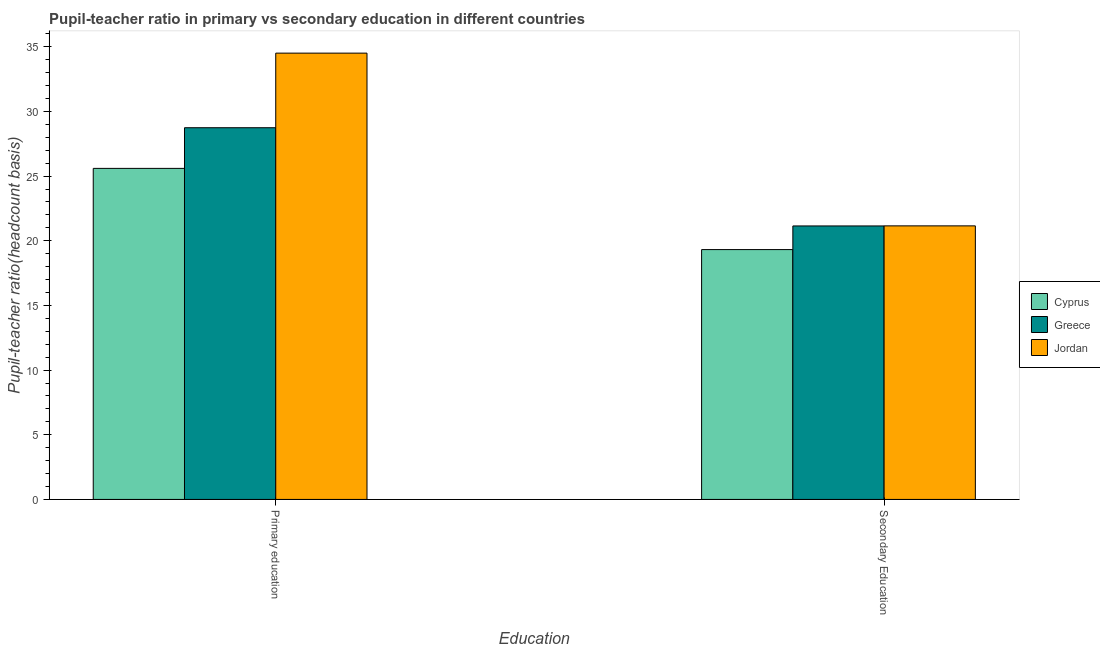How many groups of bars are there?
Provide a short and direct response. 2. Are the number of bars per tick equal to the number of legend labels?
Keep it short and to the point. Yes. What is the label of the 2nd group of bars from the left?
Your response must be concise. Secondary Education. What is the pupil-teacher ratio in primary education in Jordan?
Provide a short and direct response. 34.51. Across all countries, what is the maximum pupil teacher ratio on secondary education?
Provide a short and direct response. 21.15. Across all countries, what is the minimum pupil teacher ratio on secondary education?
Ensure brevity in your answer.  19.32. In which country was the pupil teacher ratio on secondary education maximum?
Keep it short and to the point. Jordan. In which country was the pupil-teacher ratio in primary education minimum?
Offer a very short reply. Cyprus. What is the total pupil-teacher ratio in primary education in the graph?
Provide a succinct answer. 88.85. What is the difference between the pupil teacher ratio on secondary education in Cyprus and that in Greece?
Provide a succinct answer. -1.83. What is the difference between the pupil-teacher ratio in primary education in Jordan and the pupil teacher ratio on secondary education in Greece?
Your answer should be very brief. 13.36. What is the average pupil-teacher ratio in primary education per country?
Keep it short and to the point. 29.62. What is the difference between the pupil teacher ratio on secondary education and pupil-teacher ratio in primary education in Greece?
Give a very brief answer. -7.59. In how many countries, is the pupil teacher ratio on secondary education greater than 1 ?
Provide a succinct answer. 3. What is the ratio of the pupil-teacher ratio in primary education in Jordan to that in Greece?
Keep it short and to the point. 1.2. Is the pupil teacher ratio on secondary education in Cyprus less than that in Jordan?
Provide a succinct answer. Yes. In how many countries, is the pupil-teacher ratio in primary education greater than the average pupil-teacher ratio in primary education taken over all countries?
Your answer should be compact. 1. What does the 1st bar from the left in Primary education represents?
Keep it short and to the point. Cyprus. What does the 3rd bar from the right in Primary education represents?
Ensure brevity in your answer.  Cyprus. How many bars are there?
Provide a succinct answer. 6. How many countries are there in the graph?
Your answer should be compact. 3. Are the values on the major ticks of Y-axis written in scientific E-notation?
Give a very brief answer. No. Does the graph contain any zero values?
Keep it short and to the point. No. What is the title of the graph?
Make the answer very short. Pupil-teacher ratio in primary vs secondary education in different countries. Does "Malaysia" appear as one of the legend labels in the graph?
Ensure brevity in your answer.  No. What is the label or title of the X-axis?
Ensure brevity in your answer.  Education. What is the label or title of the Y-axis?
Your answer should be compact. Pupil-teacher ratio(headcount basis). What is the Pupil-teacher ratio(headcount basis) in Cyprus in Primary education?
Provide a short and direct response. 25.6. What is the Pupil-teacher ratio(headcount basis) of Greece in Primary education?
Provide a short and direct response. 28.74. What is the Pupil-teacher ratio(headcount basis) of Jordan in Primary education?
Give a very brief answer. 34.51. What is the Pupil-teacher ratio(headcount basis) of Cyprus in Secondary Education?
Provide a succinct answer. 19.32. What is the Pupil-teacher ratio(headcount basis) of Greece in Secondary Education?
Give a very brief answer. 21.15. What is the Pupil-teacher ratio(headcount basis) in Jordan in Secondary Education?
Keep it short and to the point. 21.15. Across all Education, what is the maximum Pupil-teacher ratio(headcount basis) of Cyprus?
Give a very brief answer. 25.6. Across all Education, what is the maximum Pupil-teacher ratio(headcount basis) of Greece?
Your response must be concise. 28.74. Across all Education, what is the maximum Pupil-teacher ratio(headcount basis) of Jordan?
Your response must be concise. 34.51. Across all Education, what is the minimum Pupil-teacher ratio(headcount basis) of Cyprus?
Ensure brevity in your answer.  19.32. Across all Education, what is the minimum Pupil-teacher ratio(headcount basis) of Greece?
Your response must be concise. 21.15. Across all Education, what is the minimum Pupil-teacher ratio(headcount basis) of Jordan?
Offer a terse response. 21.15. What is the total Pupil-teacher ratio(headcount basis) in Cyprus in the graph?
Provide a short and direct response. 44.92. What is the total Pupil-teacher ratio(headcount basis) in Greece in the graph?
Give a very brief answer. 49.89. What is the total Pupil-teacher ratio(headcount basis) of Jordan in the graph?
Provide a short and direct response. 55.66. What is the difference between the Pupil-teacher ratio(headcount basis) in Cyprus in Primary education and that in Secondary Education?
Your answer should be very brief. 6.28. What is the difference between the Pupil-teacher ratio(headcount basis) of Greece in Primary education and that in Secondary Education?
Provide a succinct answer. 7.59. What is the difference between the Pupil-teacher ratio(headcount basis) in Jordan in Primary education and that in Secondary Education?
Provide a short and direct response. 13.36. What is the difference between the Pupil-teacher ratio(headcount basis) of Cyprus in Primary education and the Pupil-teacher ratio(headcount basis) of Greece in Secondary Education?
Provide a short and direct response. 4.45. What is the difference between the Pupil-teacher ratio(headcount basis) of Cyprus in Primary education and the Pupil-teacher ratio(headcount basis) of Jordan in Secondary Education?
Offer a very short reply. 4.44. What is the difference between the Pupil-teacher ratio(headcount basis) of Greece in Primary education and the Pupil-teacher ratio(headcount basis) of Jordan in Secondary Education?
Your response must be concise. 7.59. What is the average Pupil-teacher ratio(headcount basis) in Cyprus per Education?
Make the answer very short. 22.46. What is the average Pupil-teacher ratio(headcount basis) in Greece per Education?
Provide a short and direct response. 24.94. What is the average Pupil-teacher ratio(headcount basis) in Jordan per Education?
Offer a very short reply. 27.83. What is the difference between the Pupil-teacher ratio(headcount basis) of Cyprus and Pupil-teacher ratio(headcount basis) of Greece in Primary education?
Your answer should be compact. -3.14. What is the difference between the Pupil-teacher ratio(headcount basis) of Cyprus and Pupil-teacher ratio(headcount basis) of Jordan in Primary education?
Your answer should be very brief. -8.91. What is the difference between the Pupil-teacher ratio(headcount basis) in Greece and Pupil-teacher ratio(headcount basis) in Jordan in Primary education?
Offer a very short reply. -5.77. What is the difference between the Pupil-teacher ratio(headcount basis) of Cyprus and Pupil-teacher ratio(headcount basis) of Greece in Secondary Education?
Provide a succinct answer. -1.83. What is the difference between the Pupil-teacher ratio(headcount basis) of Cyprus and Pupil-teacher ratio(headcount basis) of Jordan in Secondary Education?
Keep it short and to the point. -1.83. What is the difference between the Pupil-teacher ratio(headcount basis) in Greece and Pupil-teacher ratio(headcount basis) in Jordan in Secondary Education?
Give a very brief answer. -0.01. What is the ratio of the Pupil-teacher ratio(headcount basis) in Cyprus in Primary education to that in Secondary Education?
Provide a short and direct response. 1.32. What is the ratio of the Pupil-teacher ratio(headcount basis) of Greece in Primary education to that in Secondary Education?
Provide a succinct answer. 1.36. What is the ratio of the Pupil-teacher ratio(headcount basis) in Jordan in Primary education to that in Secondary Education?
Offer a terse response. 1.63. What is the difference between the highest and the second highest Pupil-teacher ratio(headcount basis) in Cyprus?
Ensure brevity in your answer.  6.28. What is the difference between the highest and the second highest Pupil-teacher ratio(headcount basis) in Greece?
Provide a succinct answer. 7.59. What is the difference between the highest and the second highest Pupil-teacher ratio(headcount basis) in Jordan?
Offer a very short reply. 13.36. What is the difference between the highest and the lowest Pupil-teacher ratio(headcount basis) of Cyprus?
Keep it short and to the point. 6.28. What is the difference between the highest and the lowest Pupil-teacher ratio(headcount basis) of Greece?
Offer a terse response. 7.59. What is the difference between the highest and the lowest Pupil-teacher ratio(headcount basis) of Jordan?
Ensure brevity in your answer.  13.36. 